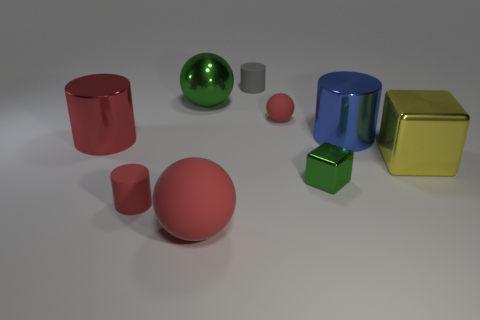There is another matte sphere that is the same color as the big rubber ball; what size is it?
Offer a terse response. Small. There is a small object behind the small rubber ball; what is its material?
Provide a succinct answer. Rubber. What is the shape of the small object that is the same color as the small rubber ball?
Provide a short and direct response. Cylinder. Are there any tiny cylinders made of the same material as the big yellow object?
Your answer should be very brief. No. What is the size of the green cube?
Provide a succinct answer. Small. What number of purple objects are either cubes or small metallic cubes?
Offer a terse response. 0. How many other objects are the same shape as the large yellow metallic thing?
Give a very brief answer. 1. What number of other metallic things have the same size as the yellow metal object?
Make the answer very short. 3. What material is the big blue object that is the same shape as the tiny gray object?
Provide a short and direct response. Metal. What is the color of the cylinder behind the blue metal thing?
Your answer should be compact. Gray. 